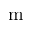Convert formula to latex. <formula><loc_0><loc_0><loc_500><loc_500>m</formula> 